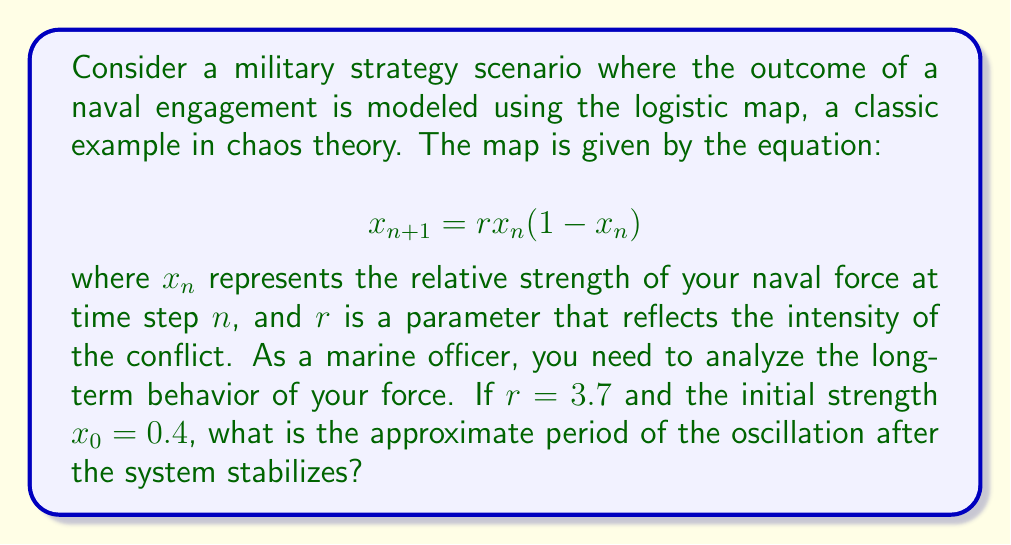Teach me how to tackle this problem. To solve this problem, we'll follow these steps:

1) First, we need to iterate the logistic map equation for several time steps to observe the long-term behavior. We'll use the given values: $r = 3.7$ and $x_0 = 0.4$.

2) Let's calculate the first few iterations:

   $x_1 = 3.7 * 0.4 * (1-0.4) = 0.888$
   $x_2 = 3.7 * 0.888 * (1-0.888) \approx 0.3684$
   $x_3 = 3.7 * 0.3684 * (1-0.3684) \approx 0.8628$
   $x_4 = 3.7 * 0.8628 * (1-0.8628) \approx 0.4397$

3) We can continue this process for more iterations, but it's clear that the values are not converging to a single point. Instead, they seem to be oscillating between multiple values.

4) For $r = 3.7$, the logistic map is known to exhibit chaotic behavior, but with some periodic windows. In this case, it falls into a period-2 oscillation after the initial transient phase.

5) To confirm this, let's continue the iterations for a few more steps:

   $x_5 \approx 0.9132$
   $x_6 \approx 0.2936$
   $x_7 \approx 0.7692$
   $x_8 \approx 0.6589$
   $x_9 \approx 0.8334$
   $x_{10} \approx 0.5152$
   $x_{11} \approx 0.9261$
   $x_{12} \approx 0.2539$

6) After these iterations, we can see that the values start to alternate between two numbers: approximately 0.2539 and 0.9261.

7) This alternation between two values indicates a period-2 oscillation.

Therefore, after the system stabilizes, it exhibits a period-2 oscillation.
Answer: 2 